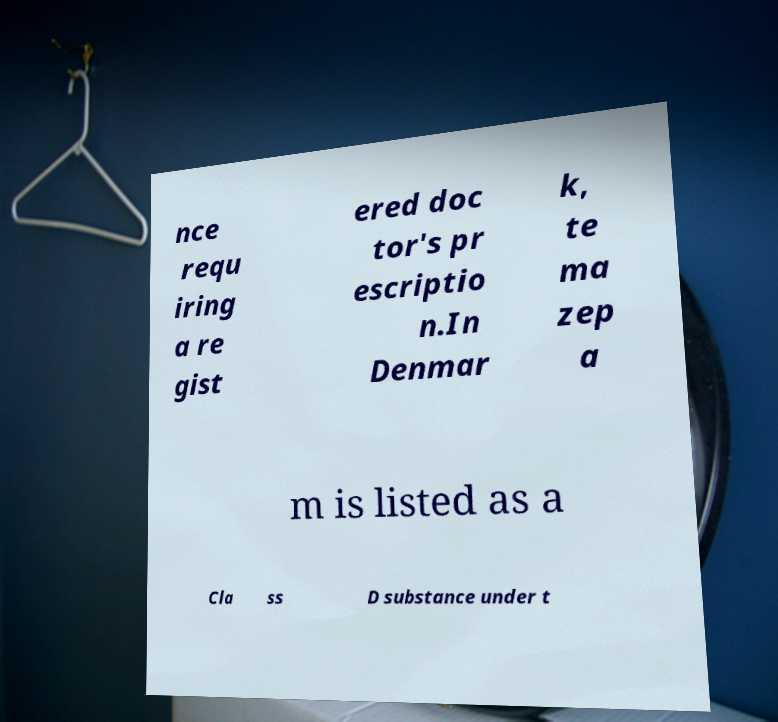There's text embedded in this image that I need extracted. Can you transcribe it verbatim? nce requ iring a re gist ered doc tor's pr escriptio n.In Denmar k, te ma zep a m is listed as a Cla ss D substance under t 